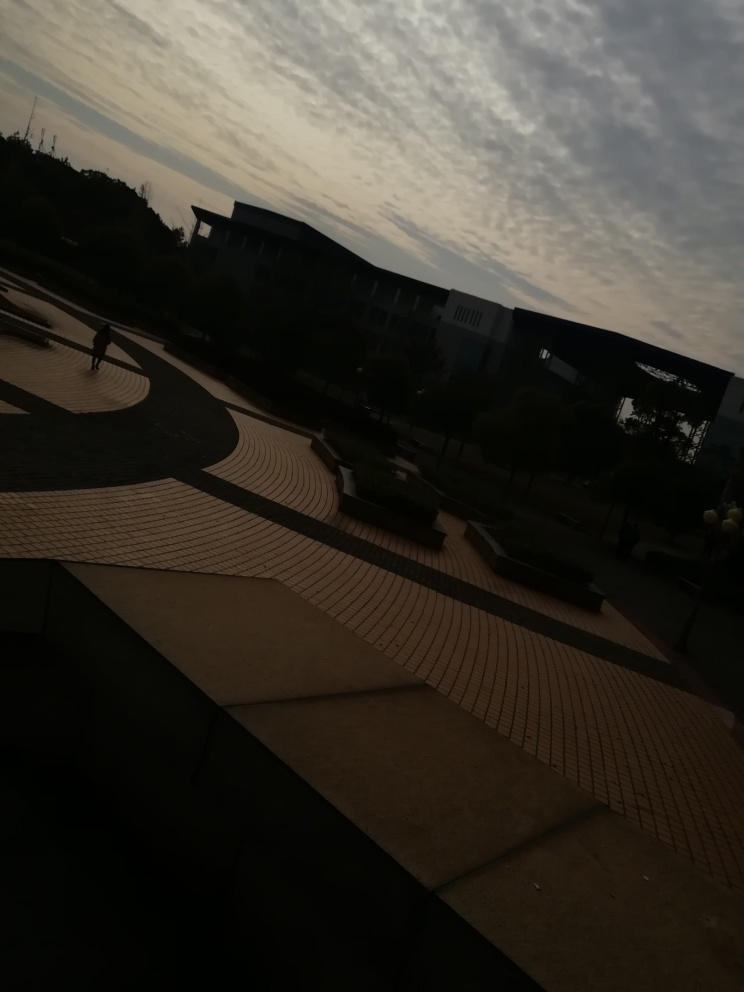What mood does this photo evoke? The photo evokes a calm and contemplative mood, heightened by the muted lighting and the expansive, uncrowded space. The combination of the architectural design and the natural sky conveys a sense of tranquility and introspection. 